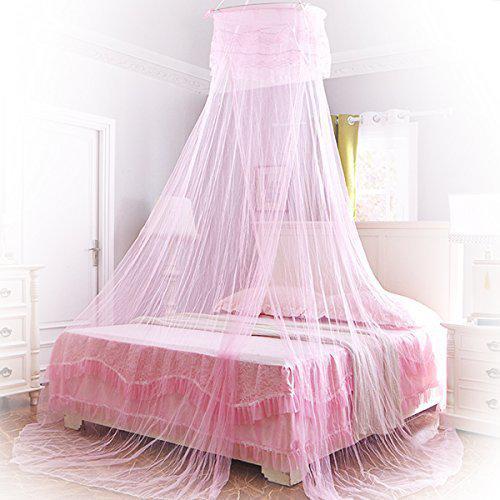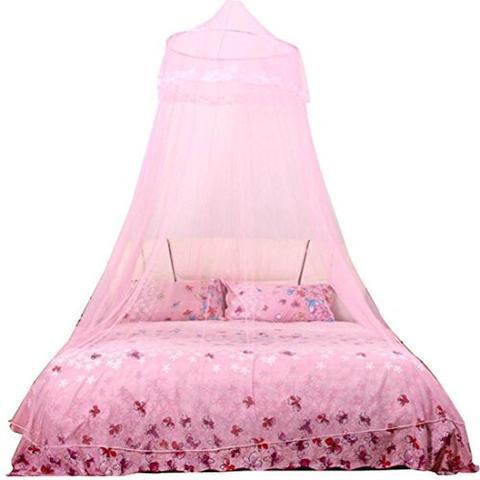The first image is the image on the left, the second image is the image on the right. Analyze the images presented: Is the assertion "Only two pillows are visible ont he right image." valid? Answer yes or no. Yes. 